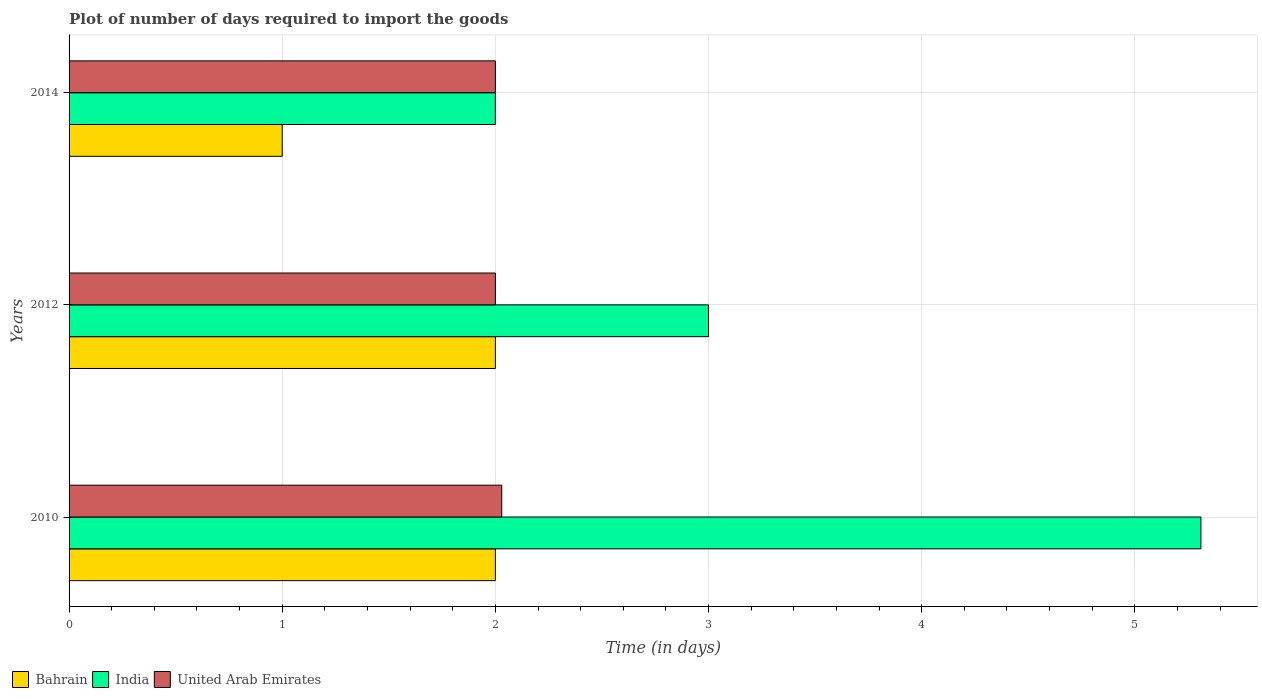Are the number of bars per tick equal to the number of legend labels?
Provide a succinct answer. Yes. Are the number of bars on each tick of the Y-axis equal?
Ensure brevity in your answer.  Yes. How many bars are there on the 1st tick from the top?
Make the answer very short. 3. In how many cases, is the number of bars for a given year not equal to the number of legend labels?
Provide a short and direct response. 0. What is the time required to import goods in Bahrain in 2014?
Provide a succinct answer. 1. Across all years, what is the maximum time required to import goods in United Arab Emirates?
Your response must be concise. 2.03. Across all years, what is the minimum time required to import goods in India?
Your answer should be very brief. 2. In which year was the time required to import goods in India minimum?
Your response must be concise. 2014. What is the total time required to import goods in Bahrain in the graph?
Your answer should be compact. 5. What is the difference between the time required to import goods in United Arab Emirates in 2010 and that in 2012?
Keep it short and to the point. 0.03. What is the average time required to import goods in Bahrain per year?
Your answer should be compact. 1.67. In how many years, is the time required to import goods in India greater than 3.2 days?
Offer a terse response. 1. What is the ratio of the time required to import goods in Bahrain in 2010 to that in 2014?
Offer a terse response. 2. Is the difference between the time required to import goods in Bahrain in 2012 and 2014 greater than the difference between the time required to import goods in India in 2012 and 2014?
Your response must be concise. No. What is the difference between the highest and the second highest time required to import goods in India?
Your answer should be compact. 2.31. What is the difference between the highest and the lowest time required to import goods in India?
Provide a succinct answer. 3.31. In how many years, is the time required to import goods in India greater than the average time required to import goods in India taken over all years?
Provide a short and direct response. 1. Is the sum of the time required to import goods in India in 2012 and 2014 greater than the maximum time required to import goods in United Arab Emirates across all years?
Provide a short and direct response. Yes. What does the 1st bar from the top in 2010 represents?
Your response must be concise. United Arab Emirates. What does the 3rd bar from the bottom in 2010 represents?
Your answer should be compact. United Arab Emirates. Is it the case that in every year, the sum of the time required to import goods in United Arab Emirates and time required to import goods in Bahrain is greater than the time required to import goods in India?
Keep it short and to the point. No. What is the difference between two consecutive major ticks on the X-axis?
Your answer should be very brief. 1. Does the graph contain any zero values?
Offer a terse response. No. Where does the legend appear in the graph?
Give a very brief answer. Bottom left. How many legend labels are there?
Keep it short and to the point. 3. What is the title of the graph?
Give a very brief answer. Plot of number of days required to import the goods. What is the label or title of the X-axis?
Offer a terse response. Time (in days). What is the Time (in days) of India in 2010?
Your answer should be compact. 5.31. What is the Time (in days) in United Arab Emirates in 2010?
Ensure brevity in your answer.  2.03. What is the Time (in days) in India in 2012?
Provide a succinct answer. 3. What is the Time (in days) of United Arab Emirates in 2012?
Give a very brief answer. 2. What is the Time (in days) of India in 2014?
Provide a succinct answer. 2. What is the Time (in days) in United Arab Emirates in 2014?
Provide a succinct answer. 2. Across all years, what is the maximum Time (in days) of Bahrain?
Provide a succinct answer. 2. Across all years, what is the maximum Time (in days) in India?
Your answer should be compact. 5.31. Across all years, what is the maximum Time (in days) in United Arab Emirates?
Make the answer very short. 2.03. What is the total Time (in days) of Bahrain in the graph?
Ensure brevity in your answer.  5. What is the total Time (in days) of India in the graph?
Offer a very short reply. 10.31. What is the total Time (in days) in United Arab Emirates in the graph?
Offer a very short reply. 6.03. What is the difference between the Time (in days) in Bahrain in 2010 and that in 2012?
Your response must be concise. 0. What is the difference between the Time (in days) in India in 2010 and that in 2012?
Offer a terse response. 2.31. What is the difference between the Time (in days) of United Arab Emirates in 2010 and that in 2012?
Your answer should be compact. 0.03. What is the difference between the Time (in days) in India in 2010 and that in 2014?
Make the answer very short. 3.31. What is the difference between the Time (in days) in United Arab Emirates in 2010 and that in 2014?
Offer a terse response. 0.03. What is the difference between the Time (in days) in Bahrain in 2012 and that in 2014?
Give a very brief answer. 1. What is the difference between the Time (in days) in India in 2012 and that in 2014?
Your answer should be very brief. 1. What is the difference between the Time (in days) in United Arab Emirates in 2012 and that in 2014?
Make the answer very short. 0. What is the difference between the Time (in days) in Bahrain in 2010 and the Time (in days) in India in 2012?
Make the answer very short. -1. What is the difference between the Time (in days) of India in 2010 and the Time (in days) of United Arab Emirates in 2012?
Give a very brief answer. 3.31. What is the difference between the Time (in days) of Bahrain in 2010 and the Time (in days) of India in 2014?
Keep it short and to the point. 0. What is the difference between the Time (in days) in India in 2010 and the Time (in days) in United Arab Emirates in 2014?
Your answer should be very brief. 3.31. What is the difference between the Time (in days) in Bahrain in 2012 and the Time (in days) in India in 2014?
Offer a very short reply. 0. What is the average Time (in days) of India per year?
Give a very brief answer. 3.44. What is the average Time (in days) of United Arab Emirates per year?
Your response must be concise. 2.01. In the year 2010, what is the difference between the Time (in days) of Bahrain and Time (in days) of India?
Provide a short and direct response. -3.31. In the year 2010, what is the difference between the Time (in days) in Bahrain and Time (in days) in United Arab Emirates?
Ensure brevity in your answer.  -0.03. In the year 2010, what is the difference between the Time (in days) of India and Time (in days) of United Arab Emirates?
Your answer should be compact. 3.28. In the year 2012, what is the difference between the Time (in days) of Bahrain and Time (in days) of United Arab Emirates?
Your answer should be very brief. 0. In the year 2014, what is the difference between the Time (in days) in Bahrain and Time (in days) in India?
Give a very brief answer. -1. What is the ratio of the Time (in days) of Bahrain in 2010 to that in 2012?
Keep it short and to the point. 1. What is the ratio of the Time (in days) in India in 2010 to that in 2012?
Make the answer very short. 1.77. What is the ratio of the Time (in days) of India in 2010 to that in 2014?
Your response must be concise. 2.65. What is the difference between the highest and the second highest Time (in days) in Bahrain?
Give a very brief answer. 0. What is the difference between the highest and the second highest Time (in days) in India?
Make the answer very short. 2.31. What is the difference between the highest and the lowest Time (in days) of India?
Keep it short and to the point. 3.31. What is the difference between the highest and the lowest Time (in days) of United Arab Emirates?
Offer a very short reply. 0.03. 